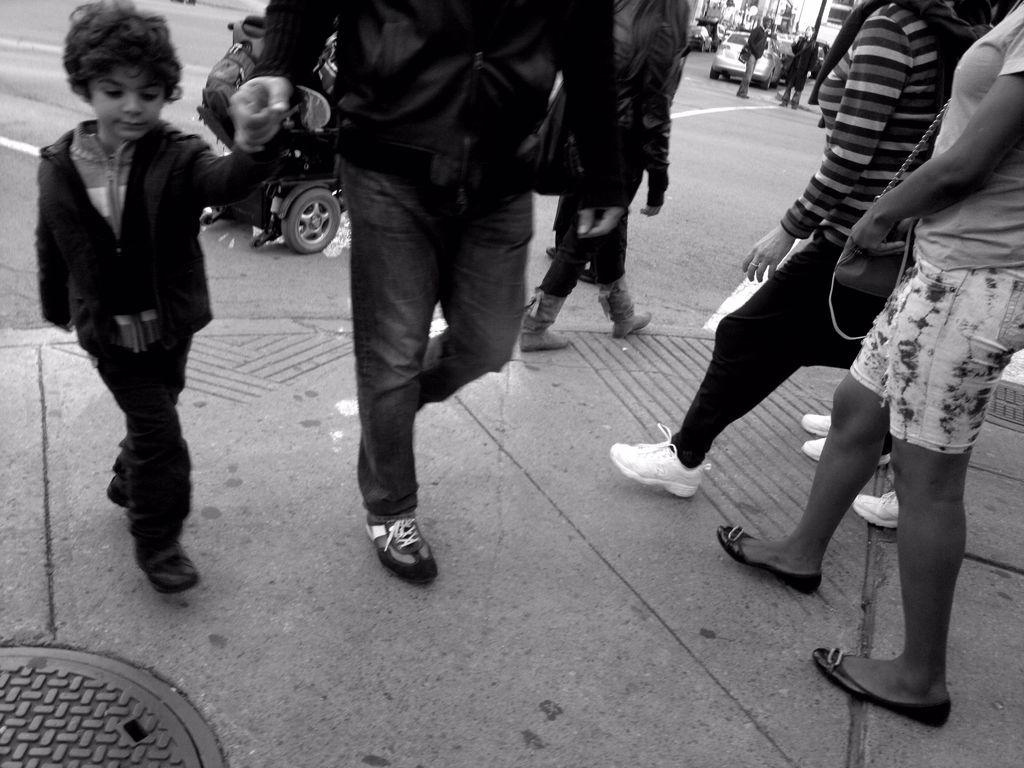How many people are in the image? There are people in the image, but the exact number is not specified. Can you describe the distribution of the people in the image? The people are scattered throughout the image. What else can be seen in the image besides the people? There is a car on the road in the image. What type of finger can be seen pointing at the car in the image? There is no finger pointing at the car in the image. What property is being sold in the image? There is no property being sold in the image; it features people and a car on the road. 